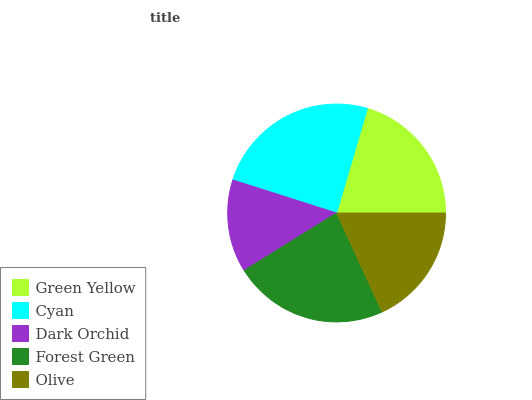Is Dark Orchid the minimum?
Answer yes or no. Yes. Is Cyan the maximum?
Answer yes or no. Yes. Is Cyan the minimum?
Answer yes or no. No. Is Dark Orchid the maximum?
Answer yes or no. No. Is Cyan greater than Dark Orchid?
Answer yes or no. Yes. Is Dark Orchid less than Cyan?
Answer yes or no. Yes. Is Dark Orchid greater than Cyan?
Answer yes or no. No. Is Cyan less than Dark Orchid?
Answer yes or no. No. Is Green Yellow the high median?
Answer yes or no. Yes. Is Green Yellow the low median?
Answer yes or no. Yes. Is Olive the high median?
Answer yes or no. No. Is Forest Green the low median?
Answer yes or no. No. 